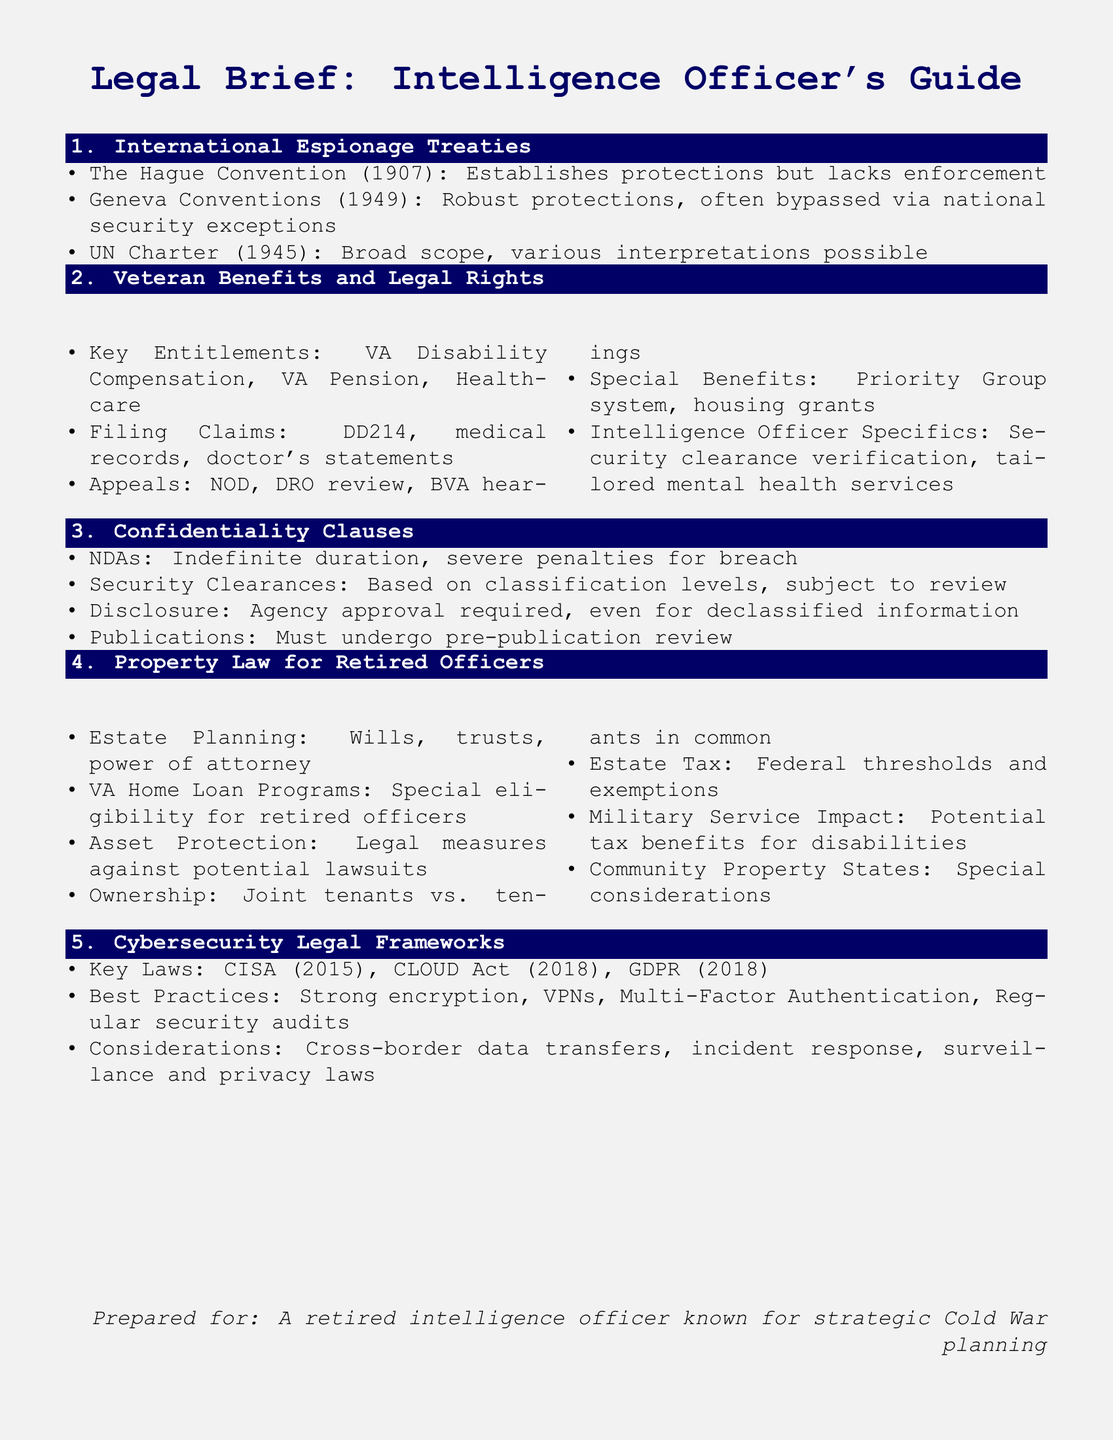What is the main legal framework discussed for cybersecurity? The document lists key laws pertaining to cybersecurity, including CISA, CLOUD Act, and GDPR.
Answer: CISA, CLOUD Act, GDPR Which treaty establishes protections for international espionage but lacks enforcement mechanisms? The Hague Convention (1907) is mentioned as establishing protections without enforcement.
Answer: The Hague Convention What specific entitlement is highlighted for retired intelligence officers regarding healthcare? The outline notes that tailored mental health services are a specific benefit for retired intelligence officers.
Answer: Tailored mental health services What type of legal agreement is discussed regarding the confidentiality of operations? The brief mentions NDAs regarding confidentiality and their penalties for breach.
Answer: NDAs What estate planning documents are mentioned in the property law section? The document lists wills, trusts, and power of attorney as part of estate planning.
Answer: Wills, trusts, power of attorney 